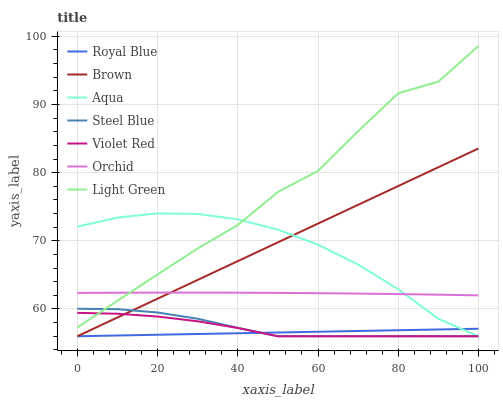Does Royal Blue have the minimum area under the curve?
Answer yes or no. Yes. Does Light Green have the maximum area under the curve?
Answer yes or no. Yes. Does Violet Red have the minimum area under the curve?
Answer yes or no. No. Does Violet Red have the maximum area under the curve?
Answer yes or no. No. Is Brown the smoothest?
Answer yes or no. Yes. Is Light Green the roughest?
Answer yes or no. Yes. Is Violet Red the smoothest?
Answer yes or no. No. Is Violet Red the roughest?
Answer yes or no. No. Does Brown have the lowest value?
Answer yes or no. Yes. Does Light Green have the lowest value?
Answer yes or no. No. Does Light Green have the highest value?
Answer yes or no. Yes. Does Violet Red have the highest value?
Answer yes or no. No. Is Violet Red less than Orchid?
Answer yes or no. Yes. Is Orchid greater than Steel Blue?
Answer yes or no. Yes. Does Aqua intersect Royal Blue?
Answer yes or no. Yes. Is Aqua less than Royal Blue?
Answer yes or no. No. Is Aqua greater than Royal Blue?
Answer yes or no. No. Does Violet Red intersect Orchid?
Answer yes or no. No. 